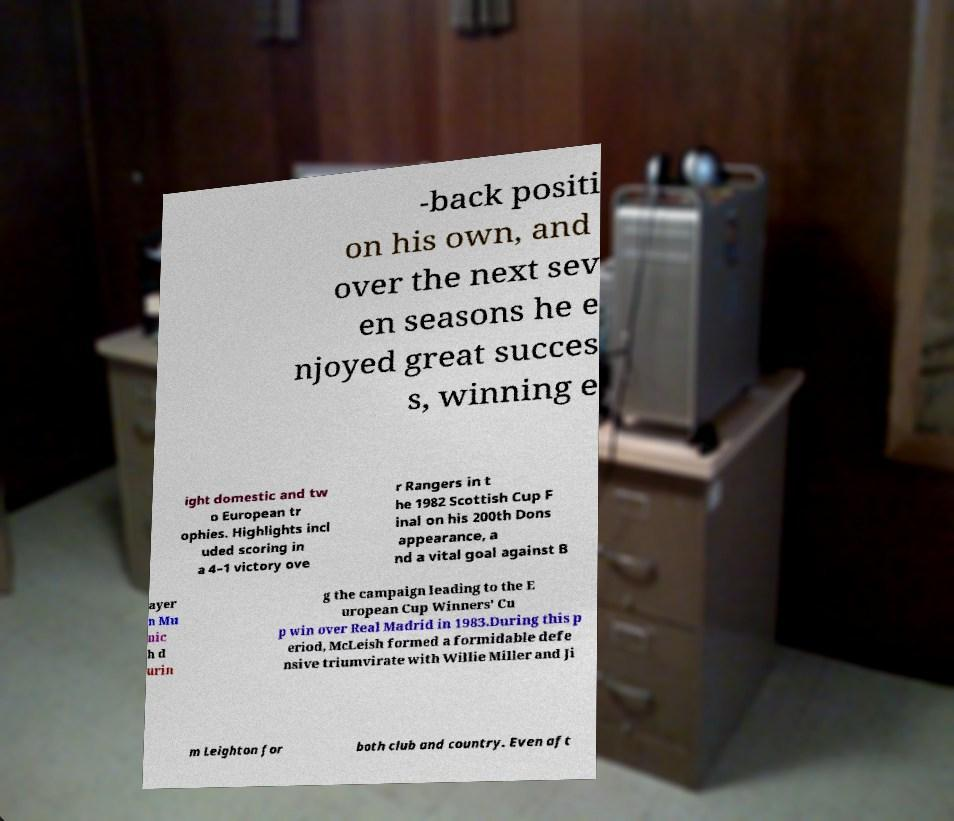There's text embedded in this image that I need extracted. Can you transcribe it verbatim? -back positi on his own, and over the next sev en seasons he e njoyed great succes s, winning e ight domestic and tw o European tr ophies. Highlights incl uded scoring in a 4–1 victory ove r Rangers in t he 1982 Scottish Cup F inal on his 200th Dons appearance, a nd a vital goal against B ayer n Mu nic h d urin g the campaign leading to the E uropean Cup Winners' Cu p win over Real Madrid in 1983.During this p eriod, McLeish formed a formidable defe nsive triumvirate with Willie Miller and Ji m Leighton for both club and country. Even aft 